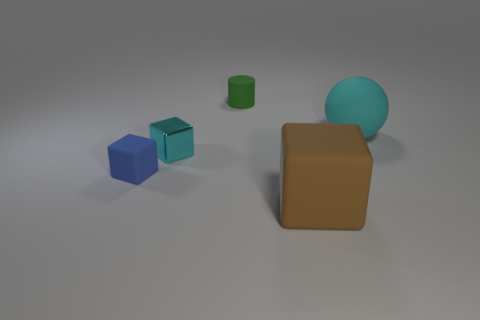Add 2 tiny yellow balls. How many objects exist? 7 Subtract all tiny blue cubes. How many cubes are left? 2 Subtract all brown cubes. How many cubes are left? 2 Subtract all cylinders. How many objects are left? 4 Subtract 1 cylinders. How many cylinders are left? 0 Add 4 small things. How many small things are left? 7 Add 4 gray rubber cylinders. How many gray rubber cylinders exist? 4 Subtract 0 yellow blocks. How many objects are left? 5 Subtract all purple cylinders. Subtract all gray spheres. How many cylinders are left? 1 Subtract all yellow cylinders. How many cyan cubes are left? 1 